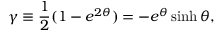<formula> <loc_0><loc_0><loc_500><loc_500>\gamma \equiv \frac { 1 } { 2 } ( 1 - e ^ { 2 \theta } ) = - e ^ { \theta } \sinh \theta ,</formula> 